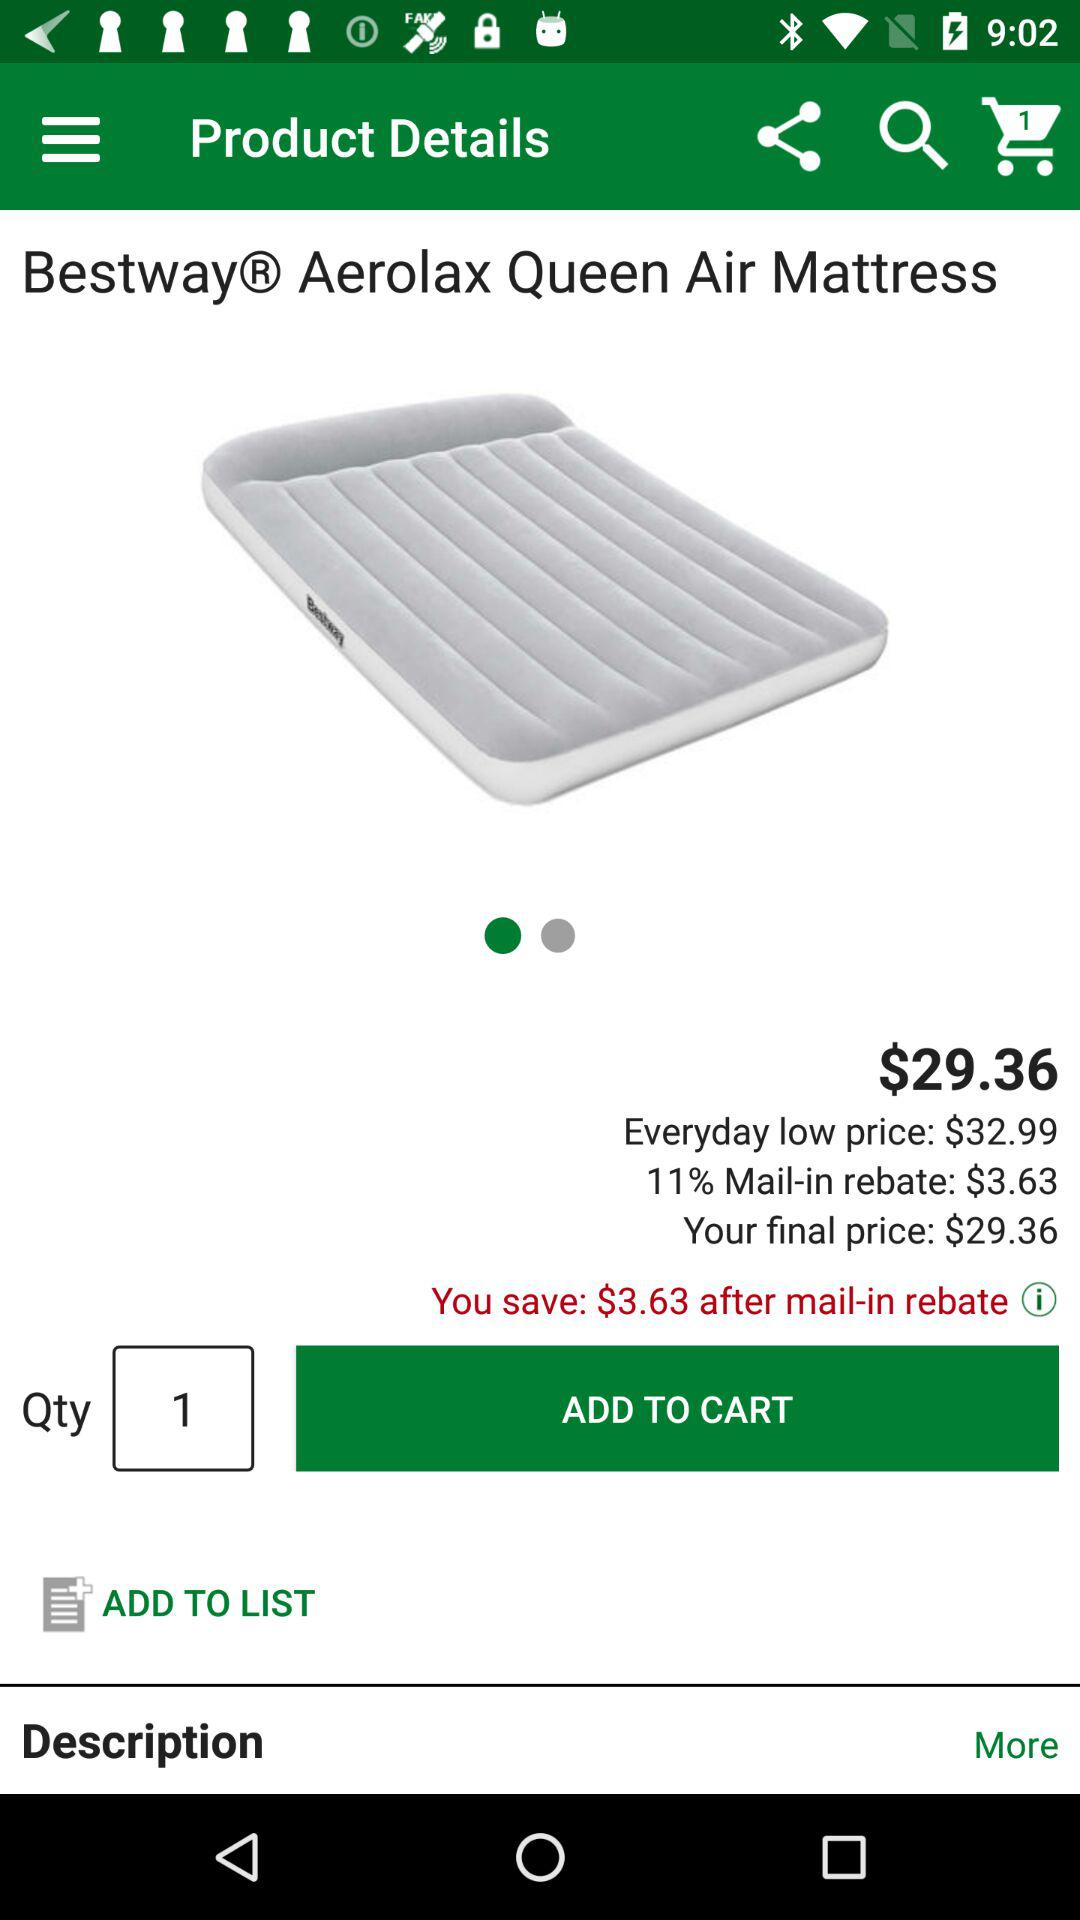How much do I save after the mail-in rebate?
Answer the question using a single word or phrase. $3.63 